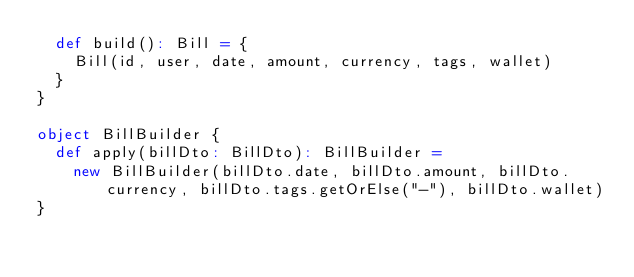Convert code to text. <code><loc_0><loc_0><loc_500><loc_500><_Scala_>  def build(): Bill = {
    Bill(id, user, date, amount, currency, tags, wallet)
  }
}

object BillBuilder {
  def apply(billDto: BillDto): BillBuilder =
    new BillBuilder(billDto.date, billDto.amount, billDto.currency, billDto.tags.getOrElse("-"), billDto.wallet)
}</code> 